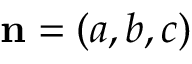Convert formula to latex. <formula><loc_0><loc_0><loc_500><loc_500>n = ( a , b , c )</formula> 